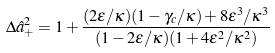<formula> <loc_0><loc_0><loc_500><loc_500>\Delta \hat { a } _ { + } ^ { 2 } = 1 + \frac { ( 2 \varepsilon / \kappa ) ( 1 - \gamma _ { c } / \kappa ) + 8 \varepsilon ^ { 3 } / \kappa ^ { 3 } } { ( 1 - 2 \varepsilon / \kappa ) ( 1 + 4 \varepsilon ^ { 2 } / \kappa ^ { 2 } ) }</formula> 